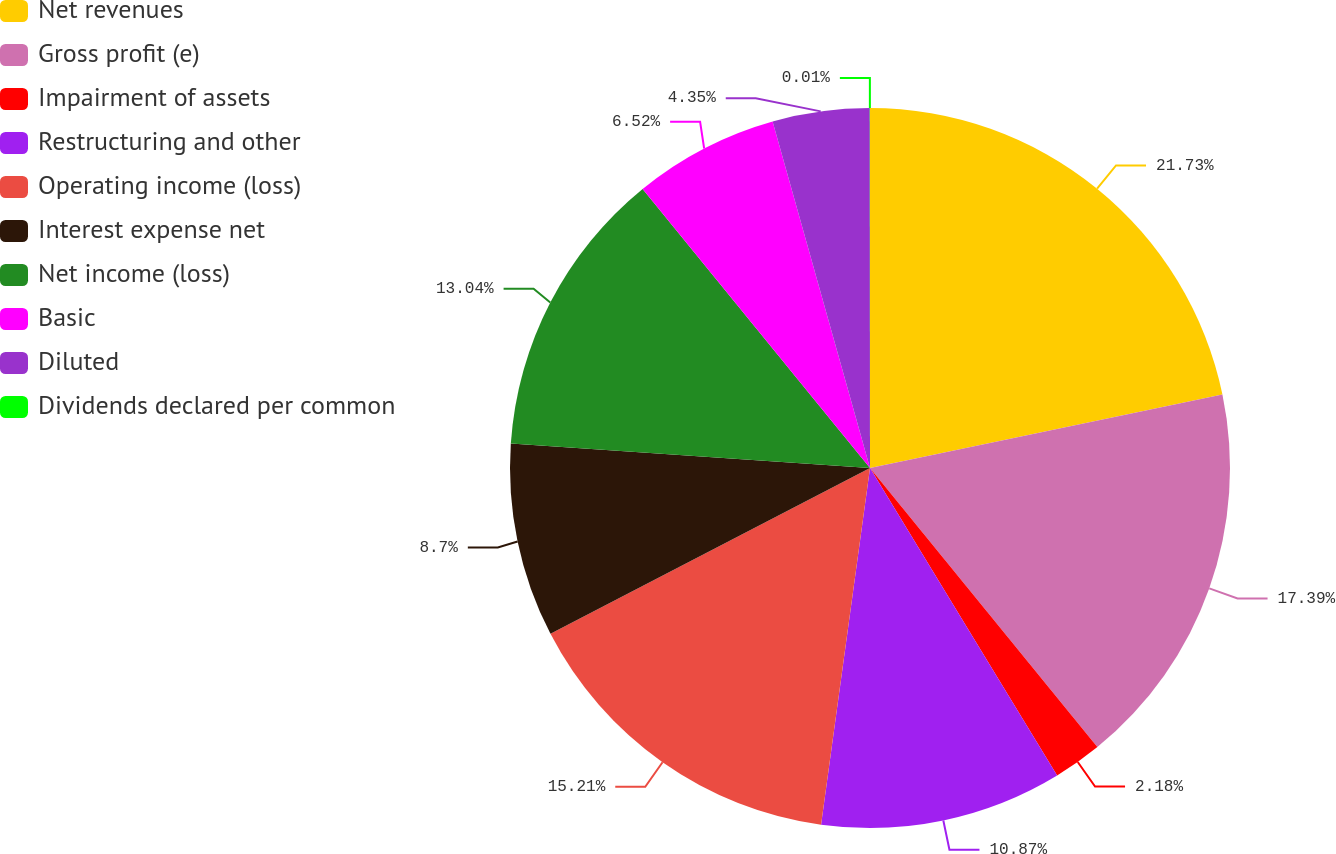<chart> <loc_0><loc_0><loc_500><loc_500><pie_chart><fcel>Net revenues<fcel>Gross profit (e)<fcel>Impairment of assets<fcel>Restructuring and other<fcel>Operating income (loss)<fcel>Interest expense net<fcel>Net income (loss)<fcel>Basic<fcel>Diluted<fcel>Dividends declared per common<nl><fcel>21.73%<fcel>17.39%<fcel>2.18%<fcel>10.87%<fcel>15.21%<fcel>8.7%<fcel>13.04%<fcel>6.52%<fcel>4.35%<fcel>0.01%<nl></chart> 